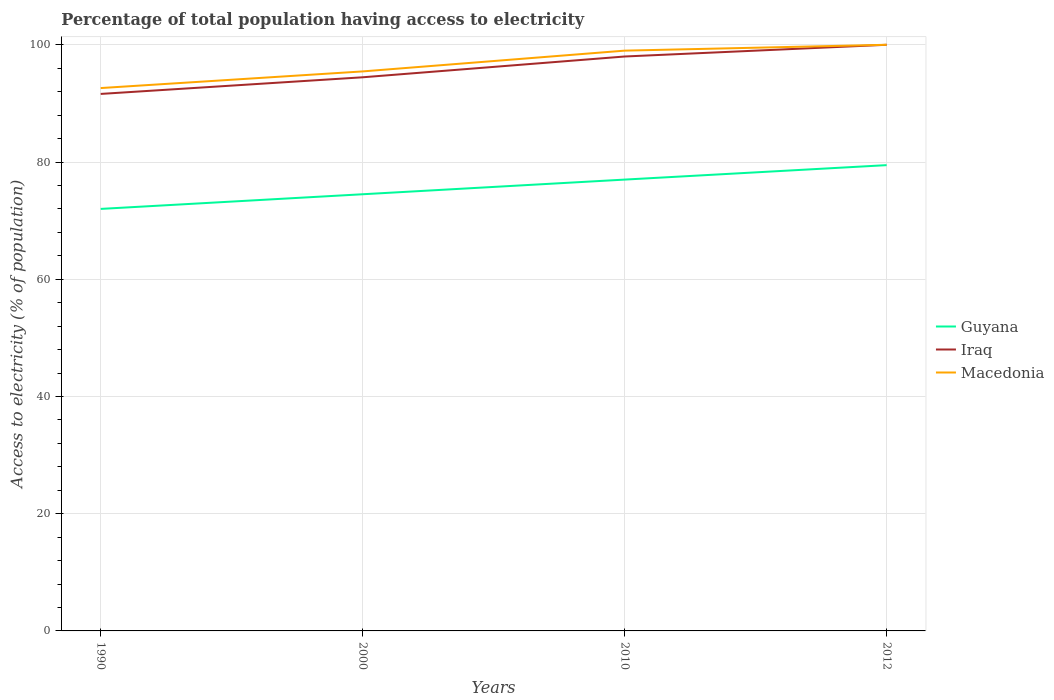Does the line corresponding to Iraq intersect with the line corresponding to Macedonia?
Offer a terse response. Yes. Across all years, what is the maximum percentage of population that have access to electricity in Iraq?
Your answer should be very brief. 91.62. In which year was the percentage of population that have access to electricity in Macedonia maximum?
Provide a short and direct response. 1990. What is the difference between the highest and the second highest percentage of population that have access to electricity in Iraq?
Offer a terse response. 8.38. What is the difference between the highest and the lowest percentage of population that have access to electricity in Iraq?
Offer a very short reply. 2. Is the percentage of population that have access to electricity in Macedonia strictly greater than the percentage of population that have access to electricity in Guyana over the years?
Give a very brief answer. No. How many years are there in the graph?
Give a very brief answer. 4. What is the difference between two consecutive major ticks on the Y-axis?
Offer a terse response. 20. Are the values on the major ticks of Y-axis written in scientific E-notation?
Your answer should be compact. No. What is the title of the graph?
Give a very brief answer. Percentage of total population having access to electricity. What is the label or title of the Y-axis?
Keep it short and to the point. Access to electricity (% of population). What is the Access to electricity (% of population) of Iraq in 1990?
Offer a terse response. 91.62. What is the Access to electricity (% of population) in Macedonia in 1990?
Make the answer very short. 92.62. What is the Access to electricity (% of population) of Guyana in 2000?
Keep it short and to the point. 74.5. What is the Access to electricity (% of population) in Iraq in 2000?
Your response must be concise. 94.46. What is the Access to electricity (% of population) of Macedonia in 2000?
Your response must be concise. 95.46. What is the Access to electricity (% of population) of Guyana in 2010?
Keep it short and to the point. 77. What is the Access to electricity (% of population) of Guyana in 2012?
Ensure brevity in your answer.  79.47. What is the Access to electricity (% of population) in Macedonia in 2012?
Keep it short and to the point. 100. Across all years, what is the maximum Access to electricity (% of population) of Guyana?
Keep it short and to the point. 79.47. Across all years, what is the maximum Access to electricity (% of population) of Macedonia?
Keep it short and to the point. 100. Across all years, what is the minimum Access to electricity (% of population) of Guyana?
Keep it short and to the point. 72. Across all years, what is the minimum Access to electricity (% of population) of Iraq?
Your response must be concise. 91.62. Across all years, what is the minimum Access to electricity (% of population) of Macedonia?
Your answer should be compact. 92.62. What is the total Access to electricity (% of population) of Guyana in the graph?
Keep it short and to the point. 302.97. What is the total Access to electricity (% of population) in Iraq in the graph?
Give a very brief answer. 384.07. What is the total Access to electricity (% of population) of Macedonia in the graph?
Offer a terse response. 387.07. What is the difference between the Access to electricity (% of population) in Iraq in 1990 and that in 2000?
Your response must be concise. -2.84. What is the difference between the Access to electricity (% of population) in Macedonia in 1990 and that in 2000?
Provide a succinct answer. -2.84. What is the difference between the Access to electricity (% of population) of Iraq in 1990 and that in 2010?
Your answer should be very brief. -6.38. What is the difference between the Access to electricity (% of population) of Macedonia in 1990 and that in 2010?
Your response must be concise. -6.38. What is the difference between the Access to electricity (% of population) of Guyana in 1990 and that in 2012?
Keep it short and to the point. -7.47. What is the difference between the Access to electricity (% of population) in Iraq in 1990 and that in 2012?
Your response must be concise. -8.38. What is the difference between the Access to electricity (% of population) in Macedonia in 1990 and that in 2012?
Make the answer very short. -7.38. What is the difference between the Access to electricity (% of population) in Iraq in 2000 and that in 2010?
Offer a terse response. -3.54. What is the difference between the Access to electricity (% of population) in Macedonia in 2000 and that in 2010?
Your response must be concise. -3.54. What is the difference between the Access to electricity (% of population) in Guyana in 2000 and that in 2012?
Your response must be concise. -4.97. What is the difference between the Access to electricity (% of population) of Iraq in 2000 and that in 2012?
Your response must be concise. -5.54. What is the difference between the Access to electricity (% of population) of Macedonia in 2000 and that in 2012?
Keep it short and to the point. -4.54. What is the difference between the Access to electricity (% of population) of Guyana in 2010 and that in 2012?
Offer a terse response. -2.47. What is the difference between the Access to electricity (% of population) in Guyana in 1990 and the Access to electricity (% of population) in Iraq in 2000?
Provide a succinct answer. -22.46. What is the difference between the Access to electricity (% of population) in Guyana in 1990 and the Access to electricity (% of population) in Macedonia in 2000?
Provide a succinct answer. -23.46. What is the difference between the Access to electricity (% of population) in Iraq in 1990 and the Access to electricity (% of population) in Macedonia in 2000?
Provide a succinct answer. -3.84. What is the difference between the Access to electricity (% of population) of Guyana in 1990 and the Access to electricity (% of population) of Macedonia in 2010?
Make the answer very short. -27. What is the difference between the Access to electricity (% of population) in Iraq in 1990 and the Access to electricity (% of population) in Macedonia in 2010?
Provide a short and direct response. -7.38. What is the difference between the Access to electricity (% of population) of Iraq in 1990 and the Access to electricity (% of population) of Macedonia in 2012?
Provide a short and direct response. -8.38. What is the difference between the Access to electricity (% of population) in Guyana in 2000 and the Access to electricity (% of population) in Iraq in 2010?
Give a very brief answer. -23.5. What is the difference between the Access to electricity (% of population) of Guyana in 2000 and the Access to electricity (% of population) of Macedonia in 2010?
Offer a terse response. -24.5. What is the difference between the Access to electricity (% of population) of Iraq in 2000 and the Access to electricity (% of population) of Macedonia in 2010?
Your answer should be very brief. -4.54. What is the difference between the Access to electricity (% of population) of Guyana in 2000 and the Access to electricity (% of population) of Iraq in 2012?
Make the answer very short. -25.5. What is the difference between the Access to electricity (% of population) in Guyana in 2000 and the Access to electricity (% of population) in Macedonia in 2012?
Ensure brevity in your answer.  -25.5. What is the difference between the Access to electricity (% of population) in Iraq in 2000 and the Access to electricity (% of population) in Macedonia in 2012?
Offer a very short reply. -5.54. What is the difference between the Access to electricity (% of population) of Guyana in 2010 and the Access to electricity (% of population) of Iraq in 2012?
Your answer should be very brief. -23. What is the difference between the Access to electricity (% of population) of Guyana in 2010 and the Access to electricity (% of population) of Macedonia in 2012?
Your answer should be very brief. -23. What is the average Access to electricity (% of population) in Guyana per year?
Your answer should be very brief. 75.74. What is the average Access to electricity (% of population) of Iraq per year?
Ensure brevity in your answer.  96.02. What is the average Access to electricity (% of population) of Macedonia per year?
Make the answer very short. 96.77. In the year 1990, what is the difference between the Access to electricity (% of population) of Guyana and Access to electricity (% of population) of Iraq?
Your answer should be very brief. -19.62. In the year 1990, what is the difference between the Access to electricity (% of population) in Guyana and Access to electricity (% of population) in Macedonia?
Make the answer very short. -20.62. In the year 1990, what is the difference between the Access to electricity (% of population) of Iraq and Access to electricity (% of population) of Macedonia?
Provide a short and direct response. -1. In the year 2000, what is the difference between the Access to electricity (% of population) of Guyana and Access to electricity (% of population) of Iraq?
Keep it short and to the point. -19.96. In the year 2000, what is the difference between the Access to electricity (% of population) in Guyana and Access to electricity (% of population) in Macedonia?
Provide a short and direct response. -20.96. In the year 2010, what is the difference between the Access to electricity (% of population) of Guyana and Access to electricity (% of population) of Iraq?
Your response must be concise. -21. In the year 2010, what is the difference between the Access to electricity (% of population) in Guyana and Access to electricity (% of population) in Macedonia?
Your answer should be compact. -22. In the year 2010, what is the difference between the Access to electricity (% of population) in Iraq and Access to electricity (% of population) in Macedonia?
Offer a very short reply. -1. In the year 2012, what is the difference between the Access to electricity (% of population) of Guyana and Access to electricity (% of population) of Iraq?
Provide a succinct answer. -20.53. In the year 2012, what is the difference between the Access to electricity (% of population) in Guyana and Access to electricity (% of population) in Macedonia?
Provide a short and direct response. -20.53. What is the ratio of the Access to electricity (% of population) of Guyana in 1990 to that in 2000?
Provide a short and direct response. 0.97. What is the ratio of the Access to electricity (% of population) of Iraq in 1990 to that in 2000?
Provide a short and direct response. 0.97. What is the ratio of the Access to electricity (% of population) of Macedonia in 1990 to that in 2000?
Ensure brevity in your answer.  0.97. What is the ratio of the Access to electricity (% of population) in Guyana in 1990 to that in 2010?
Ensure brevity in your answer.  0.94. What is the ratio of the Access to electricity (% of population) in Iraq in 1990 to that in 2010?
Provide a short and direct response. 0.93. What is the ratio of the Access to electricity (% of population) of Macedonia in 1990 to that in 2010?
Make the answer very short. 0.94. What is the ratio of the Access to electricity (% of population) in Guyana in 1990 to that in 2012?
Offer a terse response. 0.91. What is the ratio of the Access to electricity (% of population) in Iraq in 1990 to that in 2012?
Your answer should be compact. 0.92. What is the ratio of the Access to electricity (% of population) of Macedonia in 1990 to that in 2012?
Offer a very short reply. 0.93. What is the ratio of the Access to electricity (% of population) of Guyana in 2000 to that in 2010?
Offer a terse response. 0.97. What is the ratio of the Access to electricity (% of population) in Iraq in 2000 to that in 2010?
Offer a terse response. 0.96. What is the ratio of the Access to electricity (% of population) in Macedonia in 2000 to that in 2010?
Your response must be concise. 0.96. What is the ratio of the Access to electricity (% of population) in Iraq in 2000 to that in 2012?
Your answer should be very brief. 0.94. What is the ratio of the Access to electricity (% of population) of Macedonia in 2000 to that in 2012?
Offer a terse response. 0.95. What is the ratio of the Access to electricity (% of population) in Guyana in 2010 to that in 2012?
Provide a short and direct response. 0.97. What is the ratio of the Access to electricity (% of population) of Iraq in 2010 to that in 2012?
Make the answer very short. 0.98. What is the difference between the highest and the second highest Access to electricity (% of population) in Guyana?
Ensure brevity in your answer.  2.47. What is the difference between the highest and the second highest Access to electricity (% of population) in Macedonia?
Provide a short and direct response. 1. What is the difference between the highest and the lowest Access to electricity (% of population) of Guyana?
Your answer should be compact. 7.47. What is the difference between the highest and the lowest Access to electricity (% of population) of Iraq?
Offer a terse response. 8.38. What is the difference between the highest and the lowest Access to electricity (% of population) in Macedonia?
Provide a succinct answer. 7.38. 